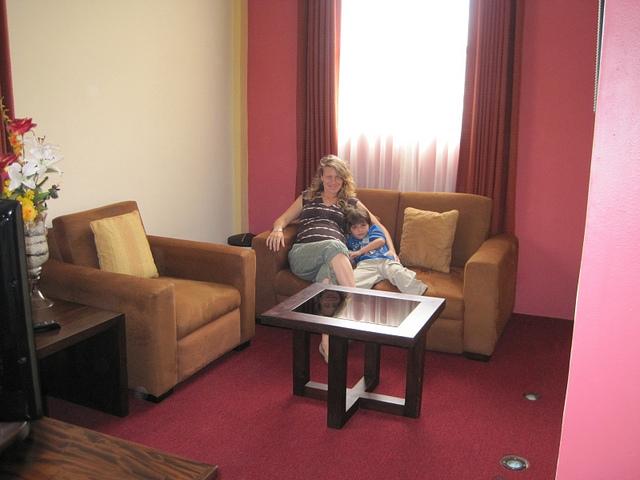Is this a bedroom?
Write a very short answer. No. How many rockers are in the picture?
Be succinct. 0. What type of flooring is visible?
Be succinct. Carpet. How many chair legs are visible?
Concise answer only. 3. What room is this?
Keep it brief. Living room. What is this used for?
Give a very brief answer. Sitting. Are there flowers in the room?
Keep it brief. Yes. How many chairs are at the table?
Give a very brief answer. 2. What shape is the table?
Short answer required. Square. What type of wood is the furniture made of?
Answer briefly. Oak. 